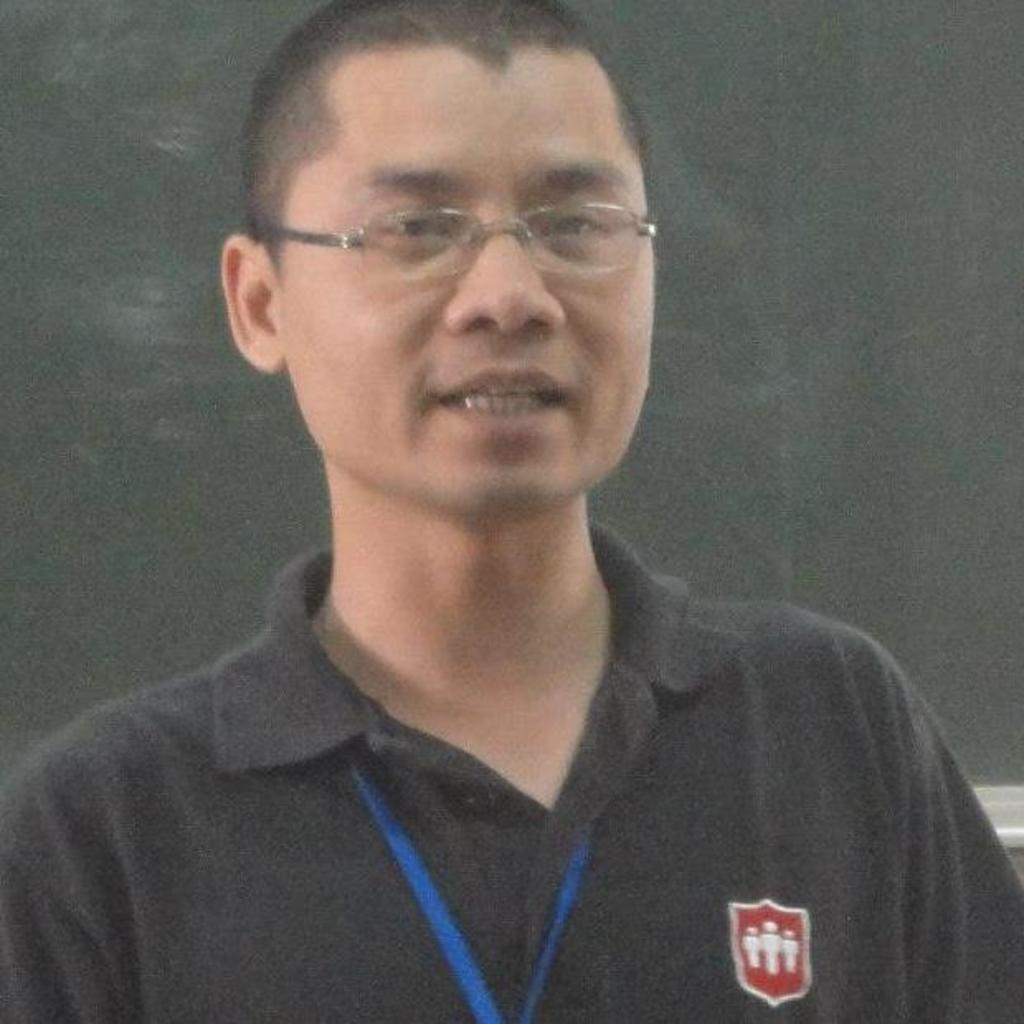What is present in the image? There is a man in the image. Can you describe the man's appearance? The man is wearing spectacles. How many times does the man fall in the image? There is no indication of the man falling in the image. What type of cannon is present in the image? There is no cannon present in the image. 